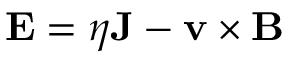Convert formula to latex. <formula><loc_0><loc_0><loc_500><loc_500>{ E } = \eta { J } - { v } \times { B }</formula> 